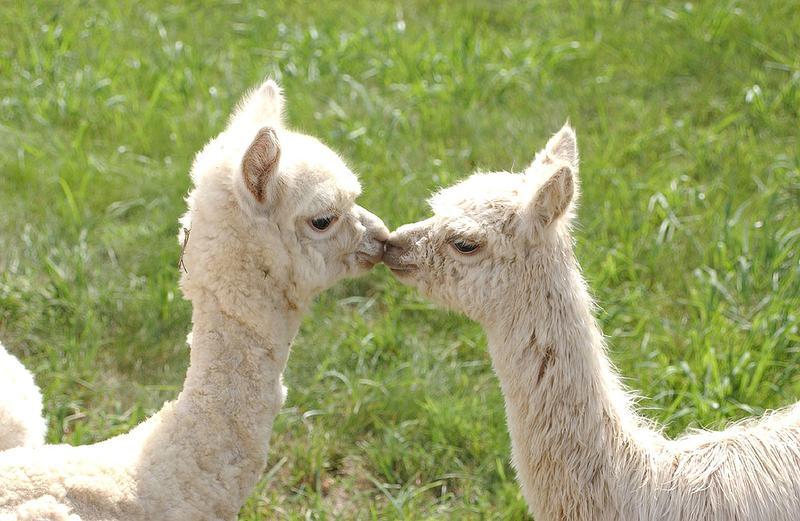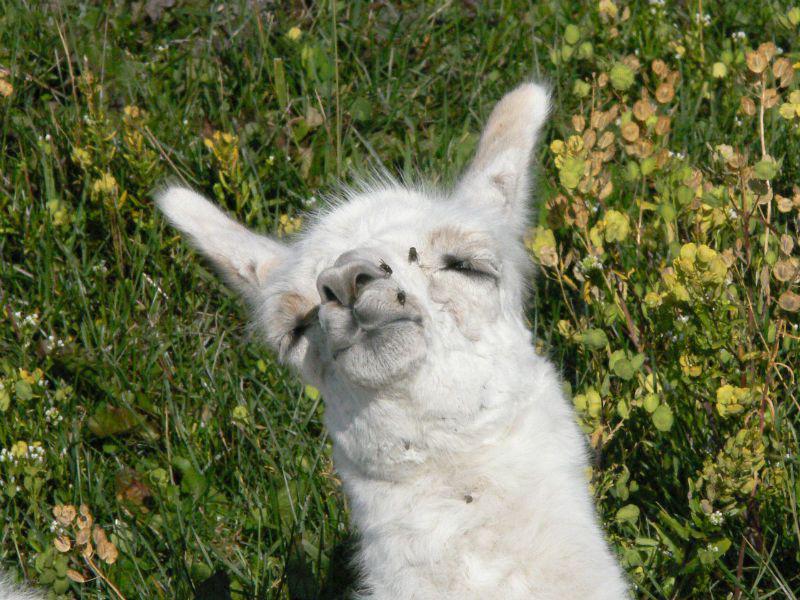The first image is the image on the left, the second image is the image on the right. Analyze the images presented: Is the assertion "There are two llamas in one image and one llama in the other." valid? Answer yes or no. Yes. The first image is the image on the left, the second image is the image on the right. Considering the images on both sides, is "All llamas are lying on the ground, and at least one llama is lying with the side of its head on the ground." valid? Answer yes or no. No. 